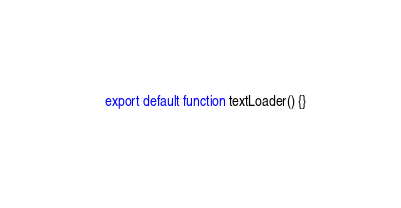<code> <loc_0><loc_0><loc_500><loc_500><_TypeScript_>export default function textLoader() {}
</code> 